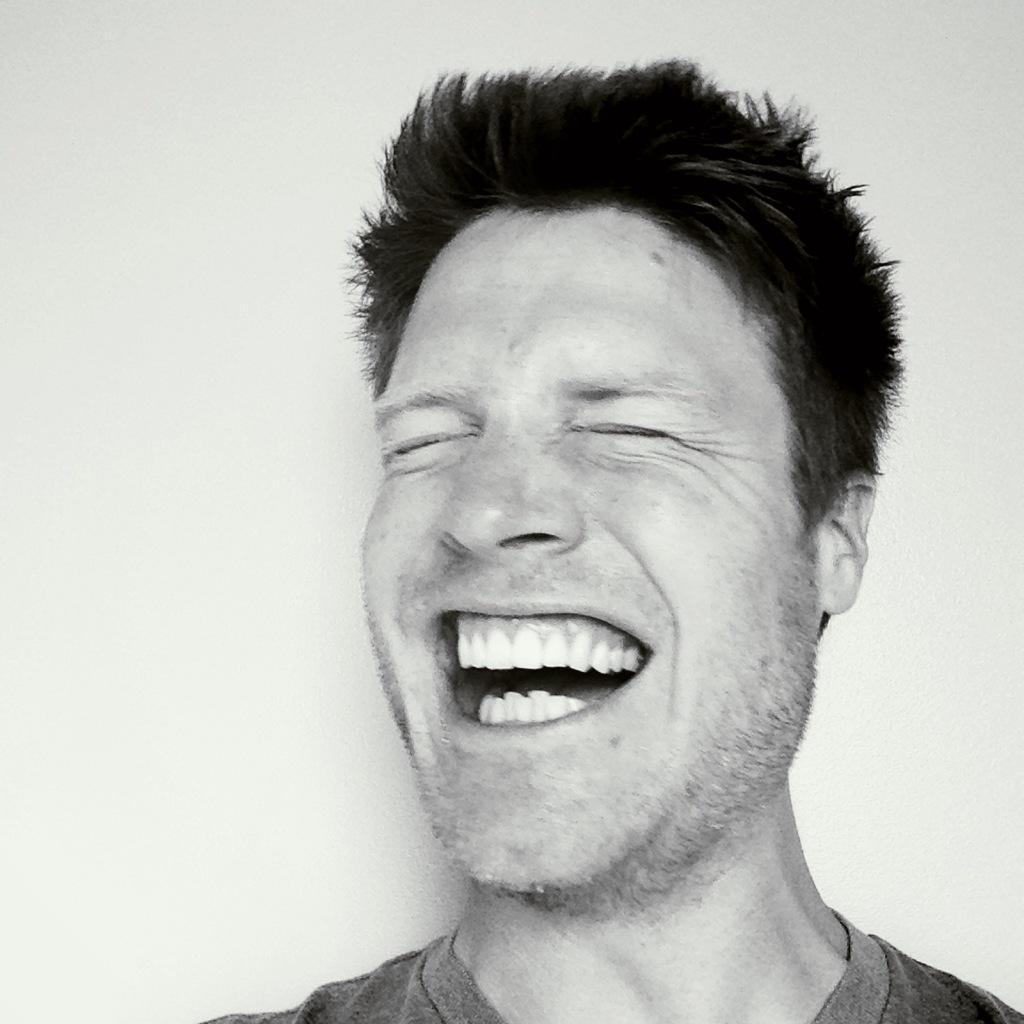Could you give a brief overview of what you see in this image? In this picture we can see a man smiling and in the background it is white color. 